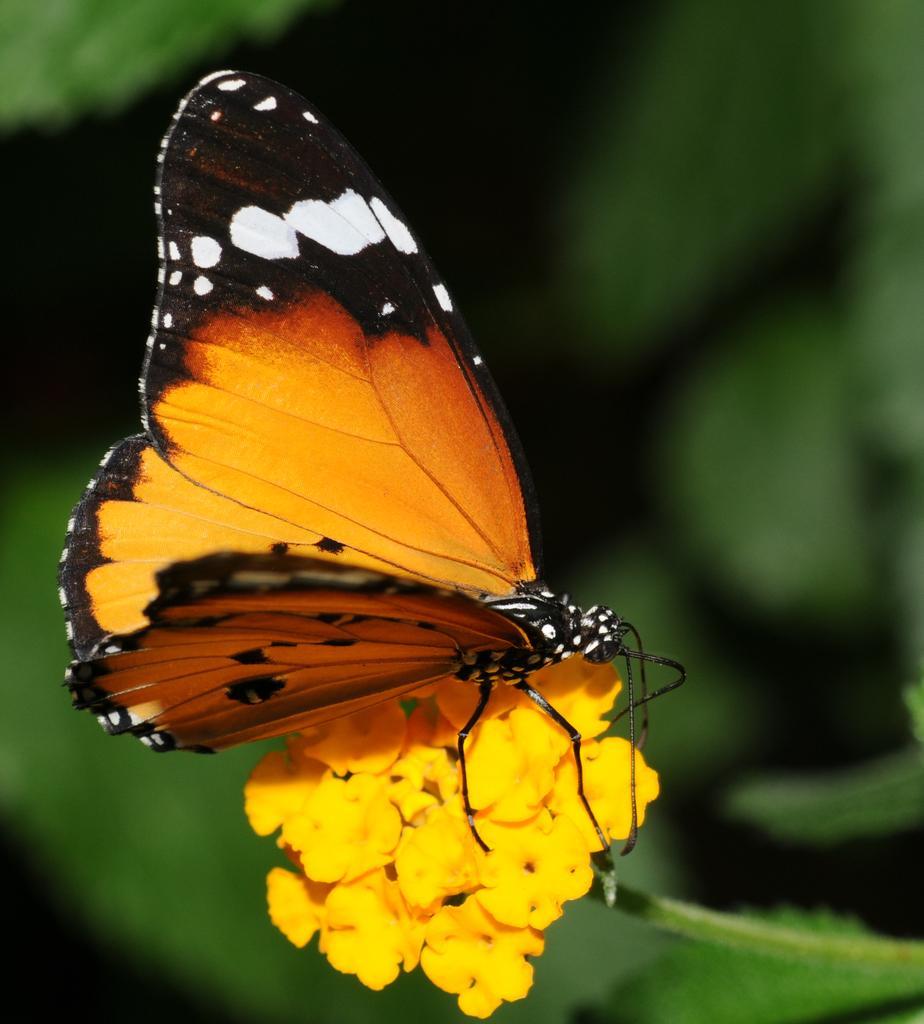In one or two sentences, can you explain what this image depicts? In this picture we can see a butterfly on the flowers. 